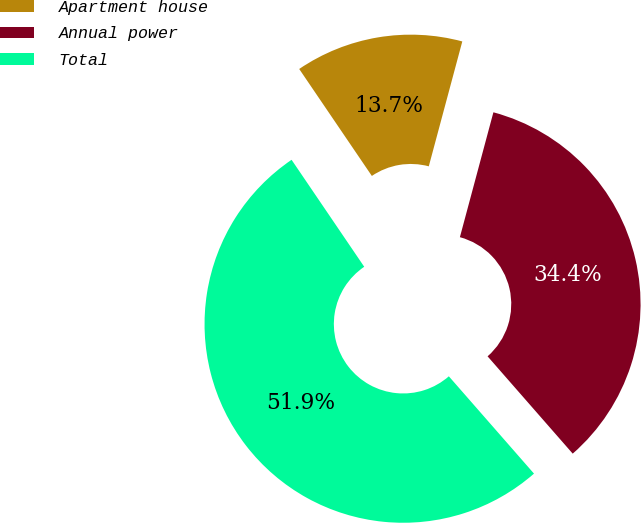Convert chart to OTSL. <chart><loc_0><loc_0><loc_500><loc_500><pie_chart><fcel>Apartment house<fcel>Annual power<fcel>Total<nl><fcel>13.67%<fcel>34.39%<fcel>51.95%<nl></chart> 